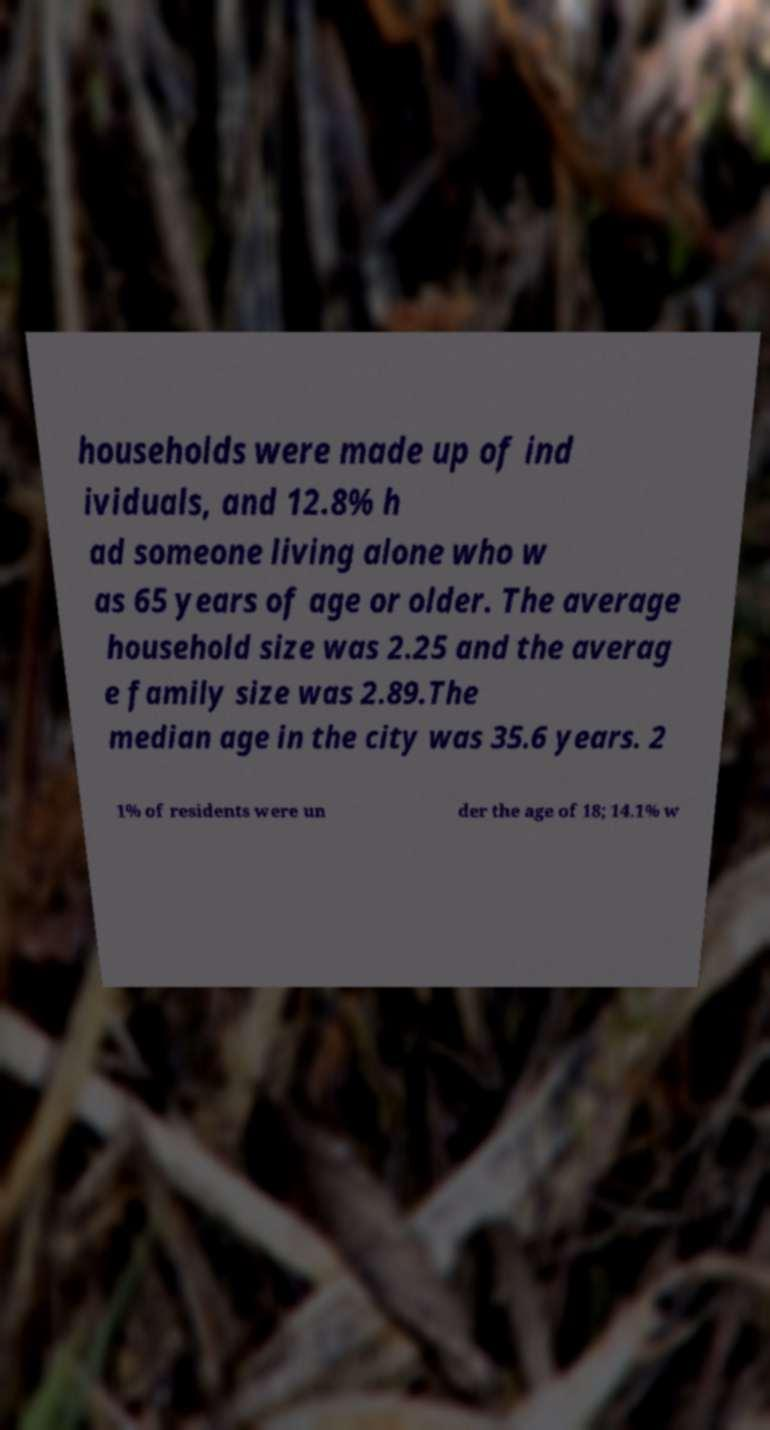What messages or text are displayed in this image? I need them in a readable, typed format. households were made up of ind ividuals, and 12.8% h ad someone living alone who w as 65 years of age or older. The average household size was 2.25 and the averag e family size was 2.89.The median age in the city was 35.6 years. 2 1% of residents were un der the age of 18; 14.1% w 